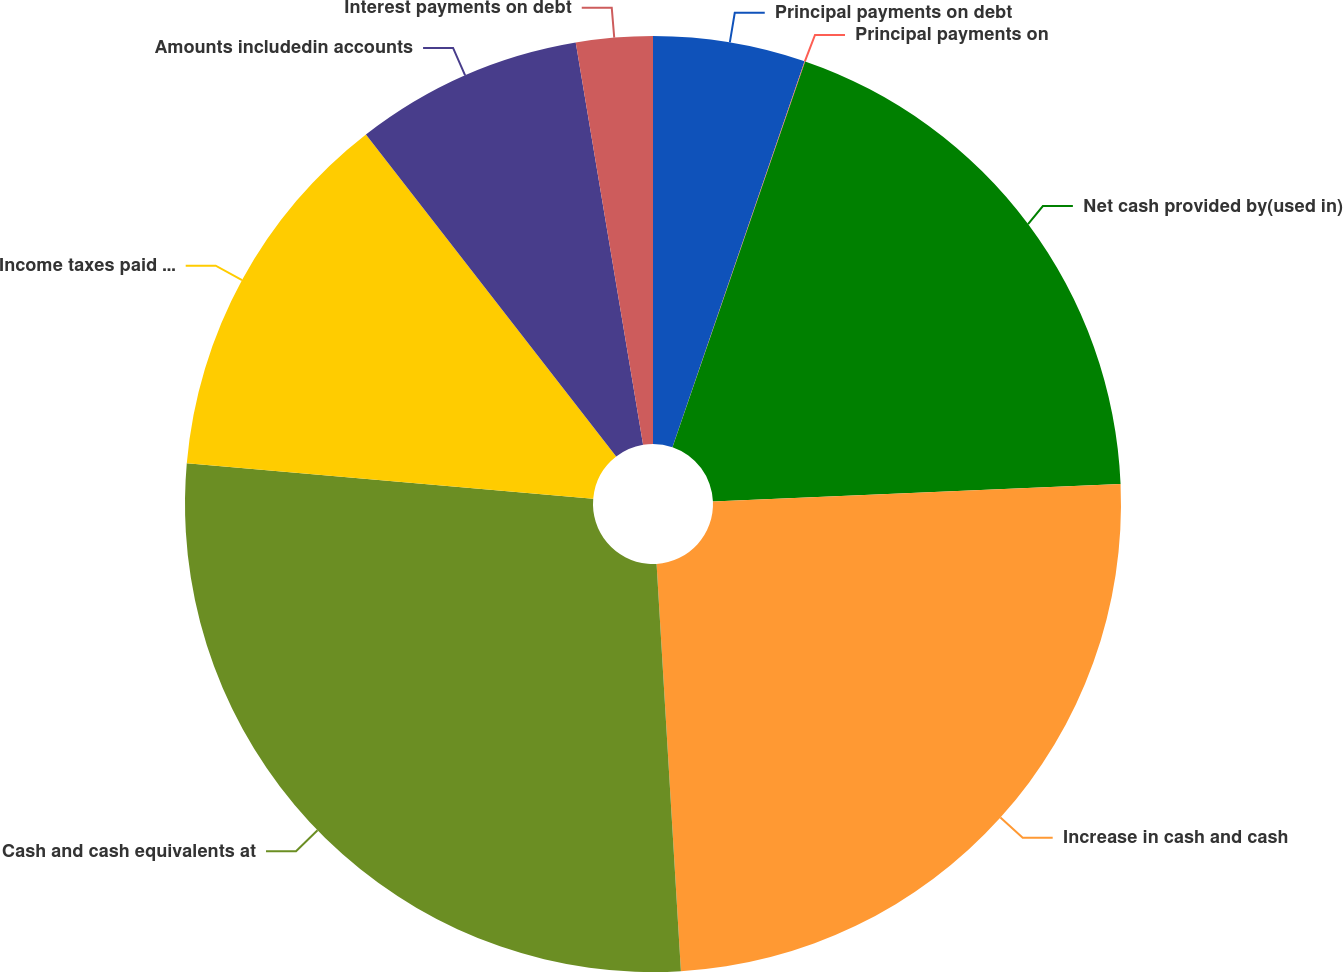<chart> <loc_0><loc_0><loc_500><loc_500><pie_chart><fcel>Principal payments on debt<fcel>Principal payments on<fcel>Net cash provided by(used in)<fcel>Increase in cash and cash<fcel>Cash and cash equivalents at<fcel>Income taxes paid net of<fcel>Amounts includedin accounts<fcel>Interest payments on debt<nl><fcel>5.25%<fcel>0.02%<fcel>19.05%<fcel>24.73%<fcel>27.34%<fcel>13.1%<fcel>7.87%<fcel>2.64%<nl></chart> 